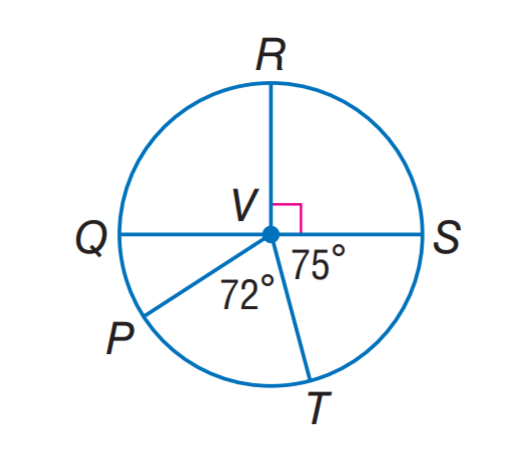Answer the mathemtical geometry problem and directly provide the correct option letter.
Question: Q S is a diameter of \odot V. Find m \widehat Q R T.
Choices: A: 105 B: 147 C: 255 D: 285 C 